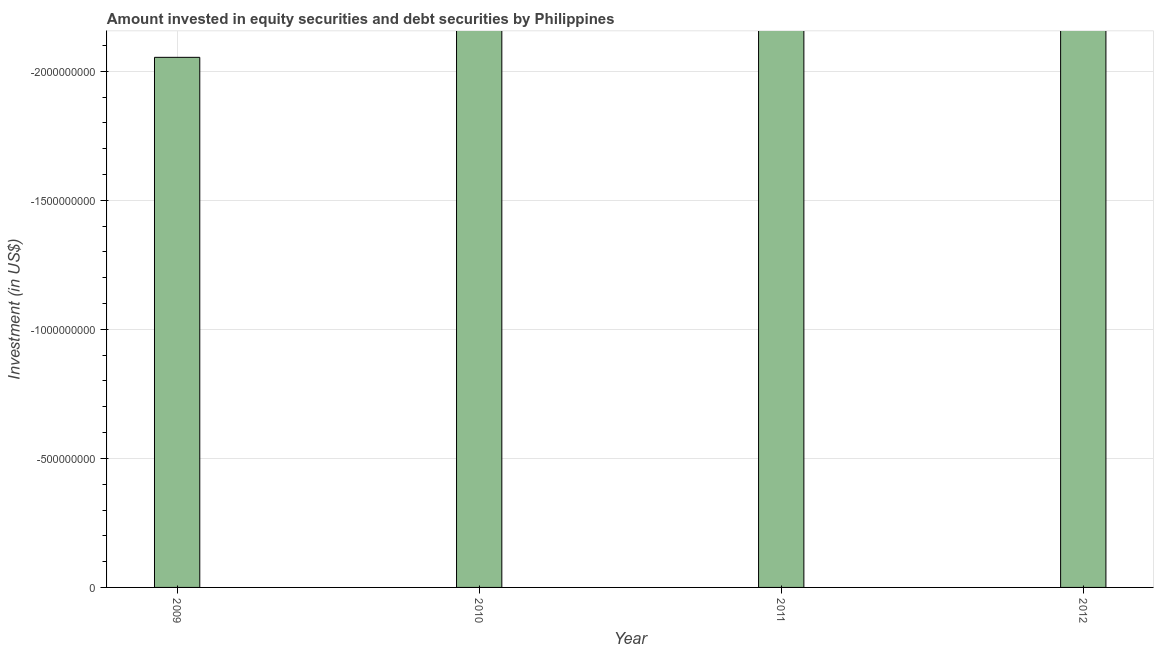What is the title of the graph?
Your answer should be compact. Amount invested in equity securities and debt securities by Philippines. What is the label or title of the X-axis?
Provide a succinct answer. Year. What is the label or title of the Y-axis?
Your response must be concise. Investment (in US$). Across all years, what is the minimum portfolio investment?
Your answer should be compact. 0. What is the sum of the portfolio investment?
Offer a very short reply. 0. What is the average portfolio investment per year?
Make the answer very short. 0. What is the median portfolio investment?
Offer a very short reply. 0. In how many years, is the portfolio investment greater than -1900000000 US$?
Your answer should be very brief. 0. In how many years, is the portfolio investment greater than the average portfolio investment taken over all years?
Offer a very short reply. 0. Are the values on the major ticks of Y-axis written in scientific E-notation?
Your response must be concise. No. What is the Investment (in US$) in 2009?
Keep it short and to the point. 0. What is the Investment (in US$) in 2010?
Ensure brevity in your answer.  0. 